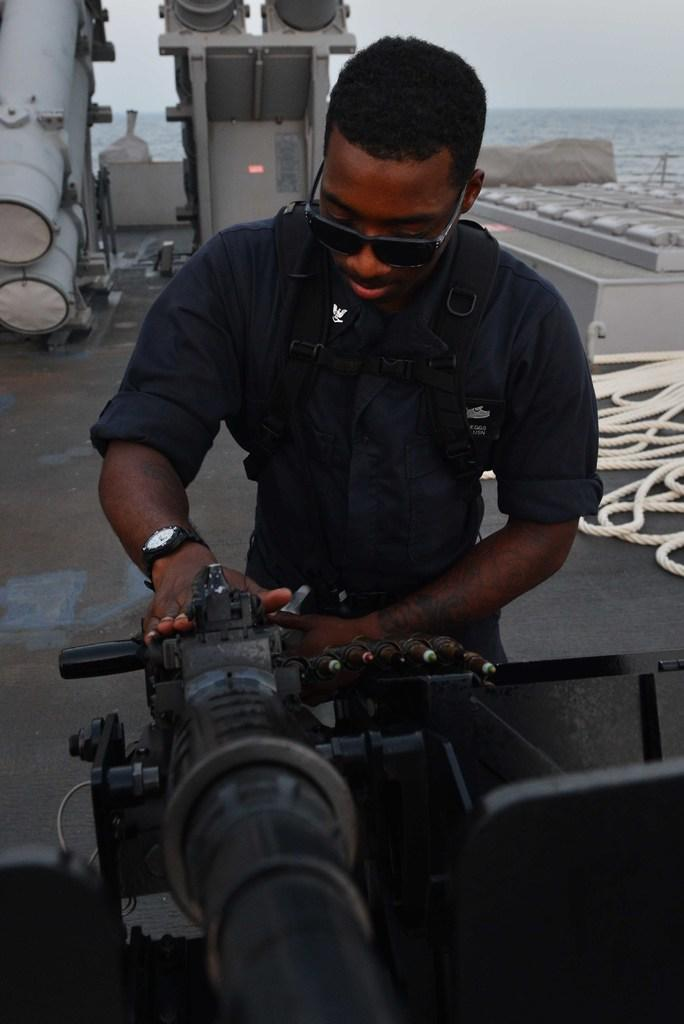What is the main subject of the image? There is a man in the image. What is the man holding in the image? The man is holding a weapon. What type of objects can be seen in the background of the image? There are metal objects in the background of the image. What is on the floor in the image? There is a rope on the floor in the image. What natural element is visible in the image? Water is visible in the image. What part of the environment is visible in the image? The sky is visible in the image. Can you tell me how many snails are crawling on the bridge in the image? There is no bridge or snails present in the image. What type of surprise is the man holding in the image? The man is holding a weapon, not a surprise, in the image. 